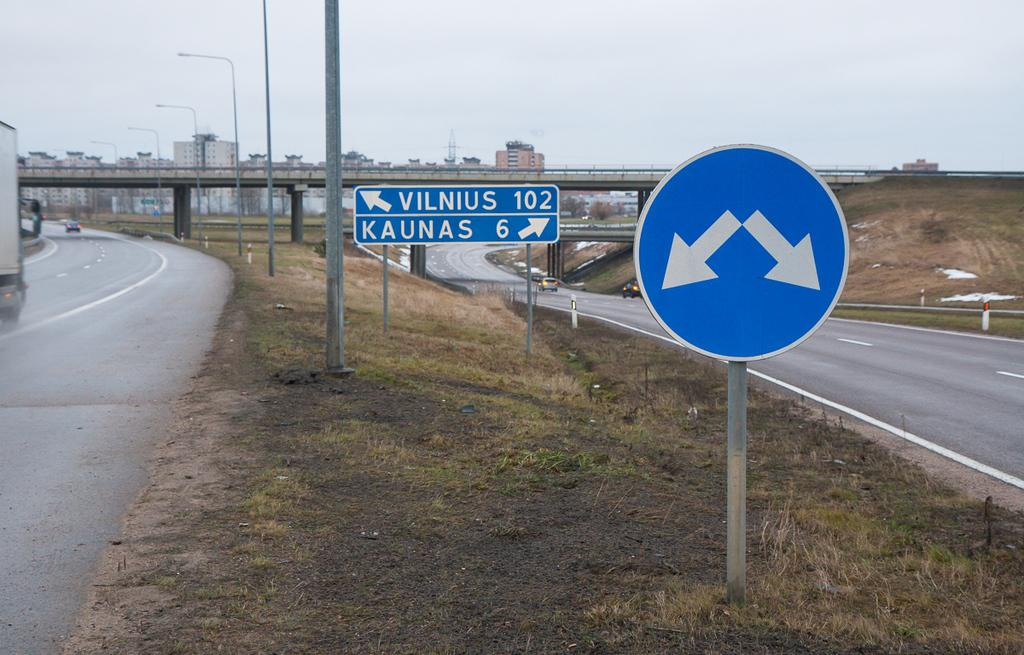<image>
Describe the image concisely. Signs on a road point to Vilnius and Kaunas. 